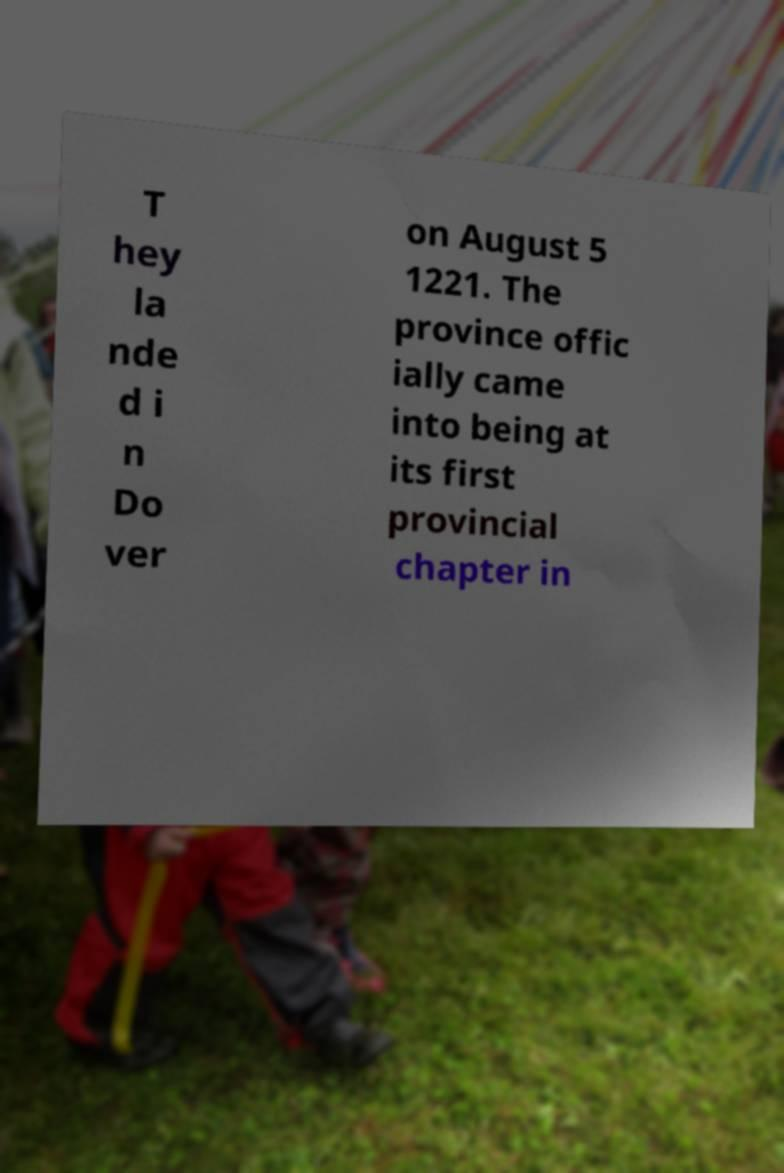There's text embedded in this image that I need extracted. Can you transcribe it verbatim? T hey la nde d i n Do ver on August 5 1221. The province offic ially came into being at its first provincial chapter in 